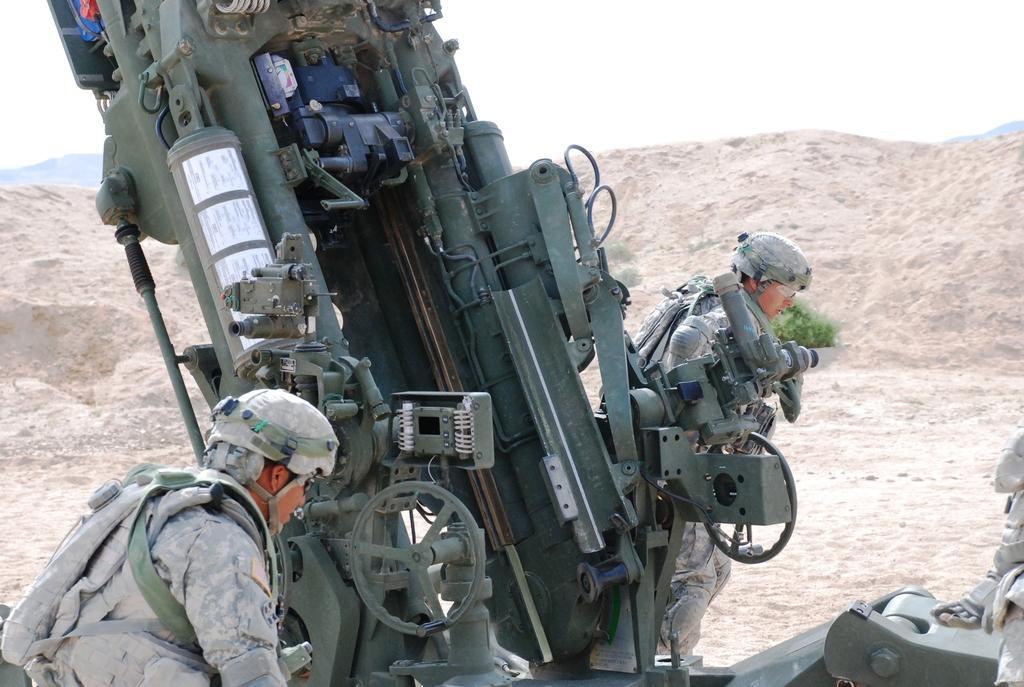Can you describe this image briefly? In the image I can see two people. I can see a vehicle. In the background, I can see it looks like a mountain. I can see the sky. 